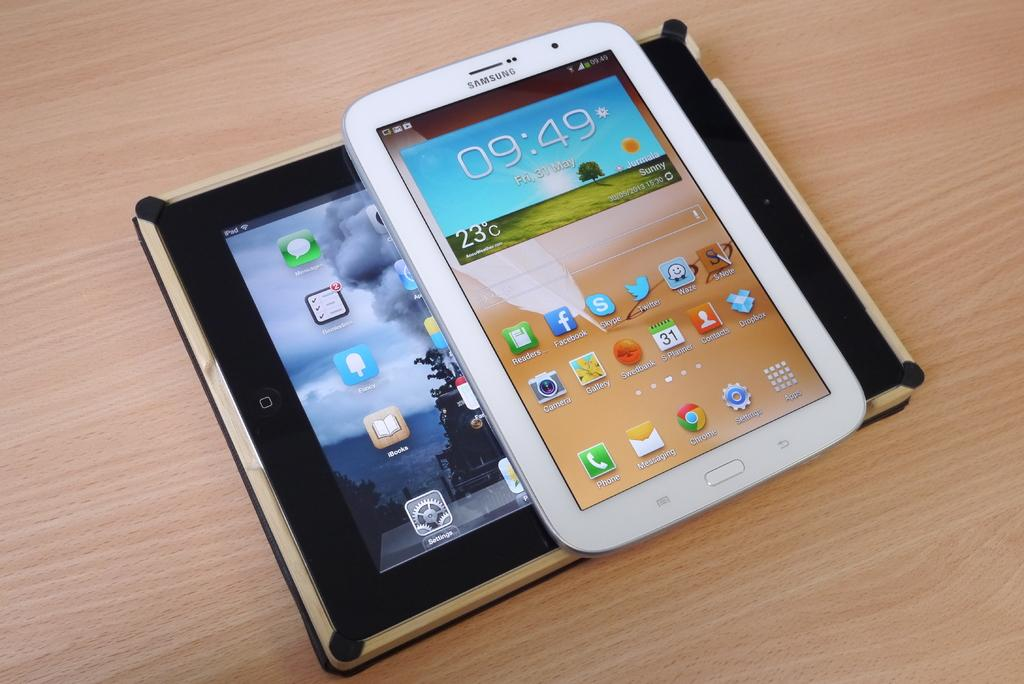How many devices can be seen in the image? There are two devices in the image. Where are the devices located? The devices are placed on a surface. Which actor is performing on the thread in the image? There is no actor or thread present in the image; it only features two devices placed on a surface. 